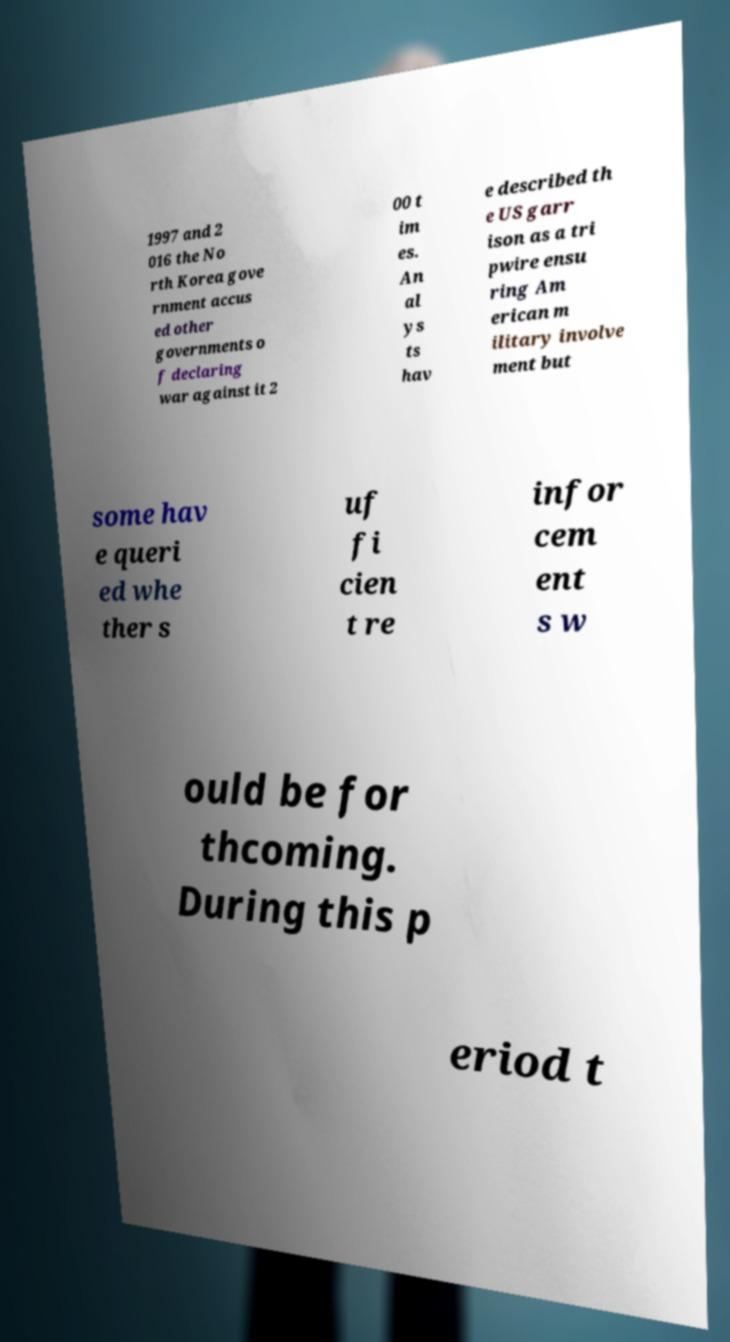Please read and relay the text visible in this image. What does it say? 1997 and 2 016 the No rth Korea gove rnment accus ed other governments o f declaring war against it 2 00 t im es. An al ys ts hav e described th e US garr ison as a tri pwire ensu ring Am erican m ilitary involve ment but some hav e queri ed whe ther s uf fi cien t re infor cem ent s w ould be for thcoming. During this p eriod t 